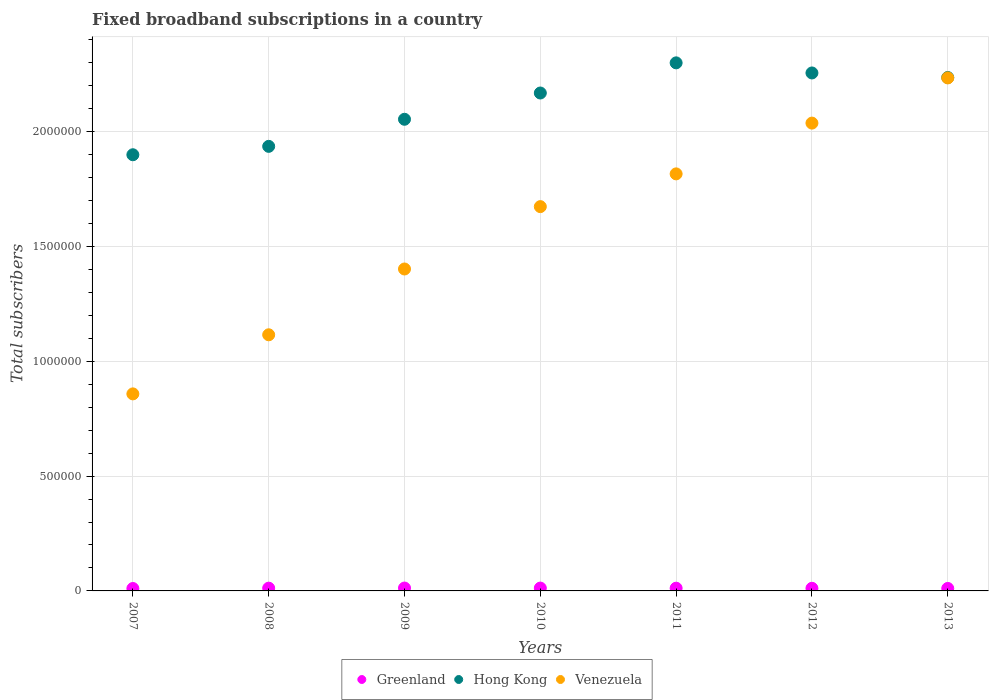How many different coloured dotlines are there?
Your answer should be compact. 3. What is the number of broadband subscriptions in Greenland in 2010?
Your answer should be compact. 1.24e+04. Across all years, what is the maximum number of broadband subscriptions in Venezuela?
Your answer should be compact. 2.23e+06. Across all years, what is the minimum number of broadband subscriptions in Greenland?
Provide a succinct answer. 1.05e+04. In which year was the number of broadband subscriptions in Venezuela minimum?
Your response must be concise. 2007. What is the total number of broadband subscriptions in Hong Kong in the graph?
Ensure brevity in your answer.  1.48e+07. What is the difference between the number of broadband subscriptions in Venezuela in 2008 and that in 2012?
Provide a short and direct response. -9.22e+05. What is the difference between the number of broadband subscriptions in Hong Kong in 2013 and the number of broadband subscriptions in Venezuela in 2007?
Offer a terse response. 1.38e+06. What is the average number of broadband subscriptions in Venezuela per year?
Provide a short and direct response. 1.59e+06. In the year 2012, what is the difference between the number of broadband subscriptions in Hong Kong and number of broadband subscriptions in Greenland?
Offer a terse response. 2.24e+06. What is the ratio of the number of broadband subscriptions in Venezuela in 2009 to that in 2010?
Provide a short and direct response. 0.84. Is the number of broadband subscriptions in Greenland in 2010 less than that in 2012?
Ensure brevity in your answer.  No. Is the difference between the number of broadband subscriptions in Hong Kong in 2009 and 2013 greater than the difference between the number of broadband subscriptions in Greenland in 2009 and 2013?
Your answer should be very brief. No. What is the difference between the highest and the second highest number of broadband subscriptions in Greenland?
Your answer should be compact. 150. What is the difference between the highest and the lowest number of broadband subscriptions in Hong Kong?
Your answer should be very brief. 4.00e+05. Is the sum of the number of broadband subscriptions in Greenland in 2009 and 2010 greater than the maximum number of broadband subscriptions in Venezuela across all years?
Provide a short and direct response. No. Is it the case that in every year, the sum of the number of broadband subscriptions in Venezuela and number of broadband subscriptions in Greenland  is greater than the number of broadband subscriptions in Hong Kong?
Provide a succinct answer. No. Is the number of broadband subscriptions in Greenland strictly greater than the number of broadband subscriptions in Hong Kong over the years?
Ensure brevity in your answer.  No. How many years are there in the graph?
Your answer should be very brief. 7. Does the graph contain any zero values?
Make the answer very short. No. Does the graph contain grids?
Give a very brief answer. Yes. Where does the legend appear in the graph?
Give a very brief answer. Bottom center. How many legend labels are there?
Your response must be concise. 3. How are the legend labels stacked?
Your response must be concise. Horizontal. What is the title of the graph?
Provide a short and direct response. Fixed broadband subscriptions in a country. Does "Central Europe" appear as one of the legend labels in the graph?
Your answer should be compact. No. What is the label or title of the Y-axis?
Keep it short and to the point. Total subscribers. What is the Total subscribers of Greenland in 2007?
Your answer should be very brief. 1.05e+04. What is the Total subscribers in Hong Kong in 2007?
Give a very brief answer. 1.90e+06. What is the Total subscribers of Venezuela in 2007?
Provide a short and direct response. 8.58e+05. What is the Total subscribers of Greenland in 2008?
Ensure brevity in your answer.  1.20e+04. What is the Total subscribers of Hong Kong in 2008?
Keep it short and to the point. 1.94e+06. What is the Total subscribers of Venezuela in 2008?
Keep it short and to the point. 1.12e+06. What is the Total subscribers in Greenland in 2009?
Offer a very short reply. 1.25e+04. What is the Total subscribers of Hong Kong in 2009?
Provide a short and direct response. 2.05e+06. What is the Total subscribers in Venezuela in 2009?
Offer a terse response. 1.40e+06. What is the Total subscribers of Greenland in 2010?
Give a very brief answer. 1.24e+04. What is the Total subscribers of Hong Kong in 2010?
Provide a short and direct response. 2.17e+06. What is the Total subscribers in Venezuela in 2010?
Give a very brief answer. 1.67e+06. What is the Total subscribers in Greenland in 2011?
Provide a short and direct response. 1.19e+04. What is the Total subscribers in Hong Kong in 2011?
Provide a short and direct response. 2.30e+06. What is the Total subscribers of Venezuela in 2011?
Your answer should be compact. 1.82e+06. What is the Total subscribers in Greenland in 2012?
Offer a terse response. 1.14e+04. What is the Total subscribers in Hong Kong in 2012?
Offer a very short reply. 2.26e+06. What is the Total subscribers of Venezuela in 2012?
Keep it short and to the point. 2.04e+06. What is the Total subscribers in Greenland in 2013?
Your answer should be compact. 1.08e+04. What is the Total subscribers of Hong Kong in 2013?
Your response must be concise. 2.24e+06. What is the Total subscribers of Venezuela in 2013?
Keep it short and to the point. 2.23e+06. Across all years, what is the maximum Total subscribers of Greenland?
Your response must be concise. 1.25e+04. Across all years, what is the maximum Total subscribers in Hong Kong?
Keep it short and to the point. 2.30e+06. Across all years, what is the maximum Total subscribers in Venezuela?
Provide a succinct answer. 2.23e+06. Across all years, what is the minimum Total subscribers of Greenland?
Make the answer very short. 1.05e+04. Across all years, what is the minimum Total subscribers in Hong Kong?
Give a very brief answer. 1.90e+06. Across all years, what is the minimum Total subscribers of Venezuela?
Keep it short and to the point. 8.58e+05. What is the total Total subscribers of Greenland in the graph?
Make the answer very short. 8.16e+04. What is the total Total subscribers in Hong Kong in the graph?
Keep it short and to the point. 1.48e+07. What is the total Total subscribers of Venezuela in the graph?
Keep it short and to the point. 1.11e+07. What is the difference between the Total subscribers in Greenland in 2007 and that in 2008?
Offer a terse response. -1466. What is the difference between the Total subscribers of Hong Kong in 2007 and that in 2008?
Your answer should be compact. -3.66e+04. What is the difference between the Total subscribers in Venezuela in 2007 and that in 2008?
Your answer should be very brief. -2.57e+05. What is the difference between the Total subscribers of Greenland in 2007 and that in 2009?
Your answer should be very brief. -1993. What is the difference between the Total subscribers of Hong Kong in 2007 and that in 2009?
Offer a very short reply. -1.54e+05. What is the difference between the Total subscribers in Venezuela in 2007 and that in 2009?
Give a very brief answer. -5.44e+05. What is the difference between the Total subscribers in Greenland in 2007 and that in 2010?
Give a very brief answer. -1843. What is the difference between the Total subscribers in Hong Kong in 2007 and that in 2010?
Your response must be concise. -2.69e+05. What is the difference between the Total subscribers in Venezuela in 2007 and that in 2010?
Your answer should be very brief. -8.15e+05. What is the difference between the Total subscribers of Greenland in 2007 and that in 2011?
Ensure brevity in your answer.  -1344. What is the difference between the Total subscribers in Hong Kong in 2007 and that in 2011?
Offer a terse response. -4.00e+05. What is the difference between the Total subscribers of Venezuela in 2007 and that in 2011?
Make the answer very short. -9.58e+05. What is the difference between the Total subscribers of Greenland in 2007 and that in 2012?
Provide a succinct answer. -833. What is the difference between the Total subscribers in Hong Kong in 2007 and that in 2012?
Keep it short and to the point. -3.56e+05. What is the difference between the Total subscribers in Venezuela in 2007 and that in 2012?
Your answer should be compact. -1.18e+06. What is the difference between the Total subscribers of Greenland in 2007 and that in 2013?
Your answer should be very brief. -253. What is the difference between the Total subscribers in Hong Kong in 2007 and that in 2013?
Ensure brevity in your answer.  -3.36e+05. What is the difference between the Total subscribers in Venezuela in 2007 and that in 2013?
Your answer should be compact. -1.38e+06. What is the difference between the Total subscribers in Greenland in 2008 and that in 2009?
Make the answer very short. -527. What is the difference between the Total subscribers of Hong Kong in 2008 and that in 2009?
Offer a very short reply. -1.18e+05. What is the difference between the Total subscribers in Venezuela in 2008 and that in 2009?
Your answer should be very brief. -2.86e+05. What is the difference between the Total subscribers of Greenland in 2008 and that in 2010?
Provide a succinct answer. -377. What is the difference between the Total subscribers in Hong Kong in 2008 and that in 2010?
Offer a very short reply. -2.32e+05. What is the difference between the Total subscribers in Venezuela in 2008 and that in 2010?
Keep it short and to the point. -5.58e+05. What is the difference between the Total subscribers of Greenland in 2008 and that in 2011?
Give a very brief answer. 122. What is the difference between the Total subscribers of Hong Kong in 2008 and that in 2011?
Ensure brevity in your answer.  -3.64e+05. What is the difference between the Total subscribers of Venezuela in 2008 and that in 2011?
Your answer should be compact. -7.01e+05. What is the difference between the Total subscribers in Greenland in 2008 and that in 2012?
Offer a very short reply. 633. What is the difference between the Total subscribers in Hong Kong in 2008 and that in 2012?
Keep it short and to the point. -3.20e+05. What is the difference between the Total subscribers in Venezuela in 2008 and that in 2012?
Offer a very short reply. -9.22e+05. What is the difference between the Total subscribers of Greenland in 2008 and that in 2013?
Offer a terse response. 1213. What is the difference between the Total subscribers in Hong Kong in 2008 and that in 2013?
Offer a very short reply. -3.00e+05. What is the difference between the Total subscribers of Venezuela in 2008 and that in 2013?
Your answer should be compact. -1.12e+06. What is the difference between the Total subscribers of Greenland in 2009 and that in 2010?
Provide a succinct answer. 150. What is the difference between the Total subscribers of Hong Kong in 2009 and that in 2010?
Offer a terse response. -1.14e+05. What is the difference between the Total subscribers of Venezuela in 2009 and that in 2010?
Ensure brevity in your answer.  -2.72e+05. What is the difference between the Total subscribers in Greenland in 2009 and that in 2011?
Give a very brief answer. 649. What is the difference between the Total subscribers of Hong Kong in 2009 and that in 2011?
Give a very brief answer. -2.46e+05. What is the difference between the Total subscribers of Venezuela in 2009 and that in 2011?
Your answer should be very brief. -4.14e+05. What is the difference between the Total subscribers of Greenland in 2009 and that in 2012?
Ensure brevity in your answer.  1160. What is the difference between the Total subscribers of Hong Kong in 2009 and that in 2012?
Give a very brief answer. -2.02e+05. What is the difference between the Total subscribers of Venezuela in 2009 and that in 2012?
Offer a very short reply. -6.35e+05. What is the difference between the Total subscribers of Greenland in 2009 and that in 2013?
Your response must be concise. 1740. What is the difference between the Total subscribers in Hong Kong in 2009 and that in 2013?
Your answer should be compact. -1.82e+05. What is the difference between the Total subscribers of Venezuela in 2009 and that in 2013?
Offer a terse response. -8.32e+05. What is the difference between the Total subscribers of Greenland in 2010 and that in 2011?
Provide a short and direct response. 499. What is the difference between the Total subscribers of Hong Kong in 2010 and that in 2011?
Ensure brevity in your answer.  -1.31e+05. What is the difference between the Total subscribers of Venezuela in 2010 and that in 2011?
Offer a terse response. -1.43e+05. What is the difference between the Total subscribers of Greenland in 2010 and that in 2012?
Give a very brief answer. 1010. What is the difference between the Total subscribers in Hong Kong in 2010 and that in 2012?
Provide a short and direct response. -8.73e+04. What is the difference between the Total subscribers of Venezuela in 2010 and that in 2012?
Offer a very short reply. -3.64e+05. What is the difference between the Total subscribers in Greenland in 2010 and that in 2013?
Make the answer very short. 1590. What is the difference between the Total subscribers of Hong Kong in 2010 and that in 2013?
Provide a short and direct response. -6.75e+04. What is the difference between the Total subscribers of Venezuela in 2010 and that in 2013?
Keep it short and to the point. -5.60e+05. What is the difference between the Total subscribers of Greenland in 2011 and that in 2012?
Provide a succinct answer. 511. What is the difference between the Total subscribers in Hong Kong in 2011 and that in 2012?
Offer a very short reply. 4.40e+04. What is the difference between the Total subscribers in Venezuela in 2011 and that in 2012?
Offer a very short reply. -2.21e+05. What is the difference between the Total subscribers in Greenland in 2011 and that in 2013?
Ensure brevity in your answer.  1091. What is the difference between the Total subscribers of Hong Kong in 2011 and that in 2013?
Give a very brief answer. 6.38e+04. What is the difference between the Total subscribers of Venezuela in 2011 and that in 2013?
Provide a short and direct response. -4.18e+05. What is the difference between the Total subscribers in Greenland in 2012 and that in 2013?
Offer a very short reply. 580. What is the difference between the Total subscribers in Hong Kong in 2012 and that in 2013?
Ensure brevity in your answer.  1.98e+04. What is the difference between the Total subscribers in Venezuela in 2012 and that in 2013?
Provide a short and direct response. -1.97e+05. What is the difference between the Total subscribers of Greenland in 2007 and the Total subscribers of Hong Kong in 2008?
Offer a terse response. -1.92e+06. What is the difference between the Total subscribers of Greenland in 2007 and the Total subscribers of Venezuela in 2008?
Your response must be concise. -1.10e+06. What is the difference between the Total subscribers of Hong Kong in 2007 and the Total subscribers of Venezuela in 2008?
Your answer should be very brief. 7.84e+05. What is the difference between the Total subscribers of Greenland in 2007 and the Total subscribers of Hong Kong in 2009?
Your answer should be very brief. -2.04e+06. What is the difference between the Total subscribers of Greenland in 2007 and the Total subscribers of Venezuela in 2009?
Keep it short and to the point. -1.39e+06. What is the difference between the Total subscribers of Hong Kong in 2007 and the Total subscribers of Venezuela in 2009?
Ensure brevity in your answer.  4.97e+05. What is the difference between the Total subscribers of Greenland in 2007 and the Total subscribers of Hong Kong in 2010?
Make the answer very short. -2.16e+06. What is the difference between the Total subscribers of Greenland in 2007 and the Total subscribers of Venezuela in 2010?
Your answer should be compact. -1.66e+06. What is the difference between the Total subscribers of Hong Kong in 2007 and the Total subscribers of Venezuela in 2010?
Your answer should be very brief. 2.26e+05. What is the difference between the Total subscribers in Greenland in 2007 and the Total subscribers in Hong Kong in 2011?
Your answer should be very brief. -2.29e+06. What is the difference between the Total subscribers of Greenland in 2007 and the Total subscribers of Venezuela in 2011?
Your response must be concise. -1.81e+06. What is the difference between the Total subscribers of Hong Kong in 2007 and the Total subscribers of Venezuela in 2011?
Offer a very short reply. 8.33e+04. What is the difference between the Total subscribers in Greenland in 2007 and the Total subscribers in Hong Kong in 2012?
Provide a succinct answer. -2.24e+06. What is the difference between the Total subscribers of Greenland in 2007 and the Total subscribers of Venezuela in 2012?
Ensure brevity in your answer.  -2.03e+06. What is the difference between the Total subscribers in Hong Kong in 2007 and the Total subscribers in Venezuela in 2012?
Keep it short and to the point. -1.38e+05. What is the difference between the Total subscribers of Greenland in 2007 and the Total subscribers of Hong Kong in 2013?
Provide a succinct answer. -2.22e+06. What is the difference between the Total subscribers in Greenland in 2007 and the Total subscribers in Venezuela in 2013?
Your response must be concise. -2.22e+06. What is the difference between the Total subscribers of Hong Kong in 2007 and the Total subscribers of Venezuela in 2013?
Your answer should be very brief. -3.34e+05. What is the difference between the Total subscribers of Greenland in 2008 and the Total subscribers of Hong Kong in 2009?
Give a very brief answer. -2.04e+06. What is the difference between the Total subscribers of Greenland in 2008 and the Total subscribers of Venezuela in 2009?
Your answer should be very brief. -1.39e+06. What is the difference between the Total subscribers in Hong Kong in 2008 and the Total subscribers in Venezuela in 2009?
Your answer should be compact. 5.34e+05. What is the difference between the Total subscribers in Greenland in 2008 and the Total subscribers in Hong Kong in 2010?
Your answer should be very brief. -2.16e+06. What is the difference between the Total subscribers in Greenland in 2008 and the Total subscribers in Venezuela in 2010?
Provide a succinct answer. -1.66e+06. What is the difference between the Total subscribers of Hong Kong in 2008 and the Total subscribers of Venezuela in 2010?
Your answer should be very brief. 2.62e+05. What is the difference between the Total subscribers of Greenland in 2008 and the Total subscribers of Hong Kong in 2011?
Your response must be concise. -2.29e+06. What is the difference between the Total subscribers of Greenland in 2008 and the Total subscribers of Venezuela in 2011?
Offer a terse response. -1.80e+06. What is the difference between the Total subscribers in Hong Kong in 2008 and the Total subscribers in Venezuela in 2011?
Give a very brief answer. 1.20e+05. What is the difference between the Total subscribers of Greenland in 2008 and the Total subscribers of Hong Kong in 2012?
Your response must be concise. -2.24e+06. What is the difference between the Total subscribers of Greenland in 2008 and the Total subscribers of Venezuela in 2012?
Keep it short and to the point. -2.02e+06. What is the difference between the Total subscribers of Hong Kong in 2008 and the Total subscribers of Venezuela in 2012?
Give a very brief answer. -1.01e+05. What is the difference between the Total subscribers of Greenland in 2008 and the Total subscribers of Hong Kong in 2013?
Offer a terse response. -2.22e+06. What is the difference between the Total subscribers in Greenland in 2008 and the Total subscribers in Venezuela in 2013?
Keep it short and to the point. -2.22e+06. What is the difference between the Total subscribers in Hong Kong in 2008 and the Total subscribers in Venezuela in 2013?
Give a very brief answer. -2.98e+05. What is the difference between the Total subscribers of Greenland in 2009 and the Total subscribers of Hong Kong in 2010?
Provide a short and direct response. -2.16e+06. What is the difference between the Total subscribers of Greenland in 2009 and the Total subscribers of Venezuela in 2010?
Offer a very short reply. -1.66e+06. What is the difference between the Total subscribers of Hong Kong in 2009 and the Total subscribers of Venezuela in 2010?
Make the answer very short. 3.80e+05. What is the difference between the Total subscribers in Greenland in 2009 and the Total subscribers in Hong Kong in 2011?
Your answer should be very brief. -2.29e+06. What is the difference between the Total subscribers in Greenland in 2009 and the Total subscribers in Venezuela in 2011?
Your answer should be very brief. -1.80e+06. What is the difference between the Total subscribers in Hong Kong in 2009 and the Total subscribers in Venezuela in 2011?
Provide a succinct answer. 2.38e+05. What is the difference between the Total subscribers of Greenland in 2009 and the Total subscribers of Hong Kong in 2012?
Your answer should be very brief. -2.24e+06. What is the difference between the Total subscribers of Greenland in 2009 and the Total subscribers of Venezuela in 2012?
Your answer should be compact. -2.02e+06. What is the difference between the Total subscribers of Hong Kong in 2009 and the Total subscribers of Venezuela in 2012?
Offer a very short reply. 1.67e+04. What is the difference between the Total subscribers in Greenland in 2009 and the Total subscribers in Hong Kong in 2013?
Ensure brevity in your answer.  -2.22e+06. What is the difference between the Total subscribers of Greenland in 2009 and the Total subscribers of Venezuela in 2013?
Your response must be concise. -2.22e+06. What is the difference between the Total subscribers in Hong Kong in 2009 and the Total subscribers in Venezuela in 2013?
Ensure brevity in your answer.  -1.80e+05. What is the difference between the Total subscribers in Greenland in 2010 and the Total subscribers in Hong Kong in 2011?
Give a very brief answer. -2.29e+06. What is the difference between the Total subscribers of Greenland in 2010 and the Total subscribers of Venezuela in 2011?
Your answer should be very brief. -1.80e+06. What is the difference between the Total subscribers in Hong Kong in 2010 and the Total subscribers in Venezuela in 2011?
Ensure brevity in your answer.  3.52e+05. What is the difference between the Total subscribers in Greenland in 2010 and the Total subscribers in Hong Kong in 2012?
Ensure brevity in your answer.  -2.24e+06. What is the difference between the Total subscribers in Greenland in 2010 and the Total subscribers in Venezuela in 2012?
Keep it short and to the point. -2.02e+06. What is the difference between the Total subscribers of Hong Kong in 2010 and the Total subscribers of Venezuela in 2012?
Your answer should be compact. 1.31e+05. What is the difference between the Total subscribers in Greenland in 2010 and the Total subscribers in Hong Kong in 2013?
Your response must be concise. -2.22e+06. What is the difference between the Total subscribers in Greenland in 2010 and the Total subscribers in Venezuela in 2013?
Make the answer very short. -2.22e+06. What is the difference between the Total subscribers of Hong Kong in 2010 and the Total subscribers of Venezuela in 2013?
Provide a succinct answer. -6.57e+04. What is the difference between the Total subscribers in Greenland in 2011 and the Total subscribers in Hong Kong in 2012?
Make the answer very short. -2.24e+06. What is the difference between the Total subscribers in Greenland in 2011 and the Total subscribers in Venezuela in 2012?
Keep it short and to the point. -2.02e+06. What is the difference between the Total subscribers in Hong Kong in 2011 and the Total subscribers in Venezuela in 2012?
Make the answer very short. 2.62e+05. What is the difference between the Total subscribers of Greenland in 2011 and the Total subscribers of Hong Kong in 2013?
Your answer should be very brief. -2.22e+06. What is the difference between the Total subscribers of Greenland in 2011 and the Total subscribers of Venezuela in 2013?
Your response must be concise. -2.22e+06. What is the difference between the Total subscribers of Hong Kong in 2011 and the Total subscribers of Venezuela in 2013?
Your answer should be compact. 6.56e+04. What is the difference between the Total subscribers of Greenland in 2012 and the Total subscribers of Hong Kong in 2013?
Your answer should be compact. -2.22e+06. What is the difference between the Total subscribers in Greenland in 2012 and the Total subscribers in Venezuela in 2013?
Make the answer very short. -2.22e+06. What is the difference between the Total subscribers in Hong Kong in 2012 and the Total subscribers in Venezuela in 2013?
Keep it short and to the point. 2.16e+04. What is the average Total subscribers of Greenland per year?
Give a very brief answer. 1.17e+04. What is the average Total subscribers of Hong Kong per year?
Your response must be concise. 2.12e+06. What is the average Total subscribers of Venezuela per year?
Keep it short and to the point. 1.59e+06. In the year 2007, what is the difference between the Total subscribers of Greenland and Total subscribers of Hong Kong?
Provide a succinct answer. -1.89e+06. In the year 2007, what is the difference between the Total subscribers in Greenland and Total subscribers in Venezuela?
Give a very brief answer. -8.47e+05. In the year 2007, what is the difference between the Total subscribers in Hong Kong and Total subscribers in Venezuela?
Keep it short and to the point. 1.04e+06. In the year 2008, what is the difference between the Total subscribers in Greenland and Total subscribers in Hong Kong?
Your answer should be very brief. -1.92e+06. In the year 2008, what is the difference between the Total subscribers of Greenland and Total subscribers of Venezuela?
Your response must be concise. -1.10e+06. In the year 2008, what is the difference between the Total subscribers of Hong Kong and Total subscribers of Venezuela?
Ensure brevity in your answer.  8.20e+05. In the year 2009, what is the difference between the Total subscribers of Greenland and Total subscribers of Hong Kong?
Ensure brevity in your answer.  -2.04e+06. In the year 2009, what is the difference between the Total subscribers of Greenland and Total subscribers of Venezuela?
Provide a short and direct response. -1.39e+06. In the year 2009, what is the difference between the Total subscribers of Hong Kong and Total subscribers of Venezuela?
Ensure brevity in your answer.  6.52e+05. In the year 2010, what is the difference between the Total subscribers in Greenland and Total subscribers in Hong Kong?
Provide a short and direct response. -2.16e+06. In the year 2010, what is the difference between the Total subscribers in Greenland and Total subscribers in Venezuela?
Provide a succinct answer. -1.66e+06. In the year 2010, what is the difference between the Total subscribers in Hong Kong and Total subscribers in Venezuela?
Offer a very short reply. 4.95e+05. In the year 2011, what is the difference between the Total subscribers of Greenland and Total subscribers of Hong Kong?
Offer a very short reply. -2.29e+06. In the year 2011, what is the difference between the Total subscribers in Greenland and Total subscribers in Venezuela?
Provide a short and direct response. -1.80e+06. In the year 2011, what is the difference between the Total subscribers in Hong Kong and Total subscribers in Venezuela?
Provide a succinct answer. 4.83e+05. In the year 2012, what is the difference between the Total subscribers of Greenland and Total subscribers of Hong Kong?
Your answer should be compact. -2.24e+06. In the year 2012, what is the difference between the Total subscribers of Greenland and Total subscribers of Venezuela?
Provide a succinct answer. -2.03e+06. In the year 2012, what is the difference between the Total subscribers of Hong Kong and Total subscribers of Venezuela?
Provide a succinct answer. 2.18e+05. In the year 2013, what is the difference between the Total subscribers in Greenland and Total subscribers in Hong Kong?
Provide a short and direct response. -2.22e+06. In the year 2013, what is the difference between the Total subscribers of Greenland and Total subscribers of Venezuela?
Keep it short and to the point. -2.22e+06. In the year 2013, what is the difference between the Total subscribers in Hong Kong and Total subscribers in Venezuela?
Provide a short and direct response. 1792. What is the ratio of the Total subscribers of Greenland in 2007 to that in 2008?
Give a very brief answer. 0.88. What is the ratio of the Total subscribers in Hong Kong in 2007 to that in 2008?
Offer a terse response. 0.98. What is the ratio of the Total subscribers in Venezuela in 2007 to that in 2008?
Offer a terse response. 0.77. What is the ratio of the Total subscribers of Greenland in 2007 to that in 2009?
Ensure brevity in your answer.  0.84. What is the ratio of the Total subscribers of Hong Kong in 2007 to that in 2009?
Your answer should be compact. 0.92. What is the ratio of the Total subscribers in Venezuela in 2007 to that in 2009?
Provide a succinct answer. 0.61. What is the ratio of the Total subscribers in Greenland in 2007 to that in 2010?
Offer a very short reply. 0.85. What is the ratio of the Total subscribers of Hong Kong in 2007 to that in 2010?
Offer a terse response. 0.88. What is the ratio of the Total subscribers of Venezuela in 2007 to that in 2010?
Offer a terse response. 0.51. What is the ratio of the Total subscribers in Greenland in 2007 to that in 2011?
Your answer should be very brief. 0.89. What is the ratio of the Total subscribers in Hong Kong in 2007 to that in 2011?
Keep it short and to the point. 0.83. What is the ratio of the Total subscribers of Venezuela in 2007 to that in 2011?
Your response must be concise. 0.47. What is the ratio of the Total subscribers of Greenland in 2007 to that in 2012?
Your answer should be compact. 0.93. What is the ratio of the Total subscribers in Hong Kong in 2007 to that in 2012?
Make the answer very short. 0.84. What is the ratio of the Total subscribers of Venezuela in 2007 to that in 2012?
Keep it short and to the point. 0.42. What is the ratio of the Total subscribers of Greenland in 2007 to that in 2013?
Offer a terse response. 0.98. What is the ratio of the Total subscribers of Hong Kong in 2007 to that in 2013?
Your answer should be compact. 0.85. What is the ratio of the Total subscribers of Venezuela in 2007 to that in 2013?
Make the answer very short. 0.38. What is the ratio of the Total subscribers of Greenland in 2008 to that in 2009?
Your response must be concise. 0.96. What is the ratio of the Total subscribers in Hong Kong in 2008 to that in 2009?
Keep it short and to the point. 0.94. What is the ratio of the Total subscribers of Venezuela in 2008 to that in 2009?
Offer a very short reply. 0.8. What is the ratio of the Total subscribers in Greenland in 2008 to that in 2010?
Give a very brief answer. 0.97. What is the ratio of the Total subscribers of Hong Kong in 2008 to that in 2010?
Keep it short and to the point. 0.89. What is the ratio of the Total subscribers in Venezuela in 2008 to that in 2010?
Your answer should be very brief. 0.67. What is the ratio of the Total subscribers of Greenland in 2008 to that in 2011?
Keep it short and to the point. 1.01. What is the ratio of the Total subscribers of Hong Kong in 2008 to that in 2011?
Your answer should be very brief. 0.84. What is the ratio of the Total subscribers of Venezuela in 2008 to that in 2011?
Your answer should be very brief. 0.61. What is the ratio of the Total subscribers in Greenland in 2008 to that in 2012?
Give a very brief answer. 1.06. What is the ratio of the Total subscribers in Hong Kong in 2008 to that in 2012?
Your response must be concise. 0.86. What is the ratio of the Total subscribers of Venezuela in 2008 to that in 2012?
Provide a short and direct response. 0.55. What is the ratio of the Total subscribers of Greenland in 2008 to that in 2013?
Keep it short and to the point. 1.11. What is the ratio of the Total subscribers of Hong Kong in 2008 to that in 2013?
Your answer should be very brief. 0.87. What is the ratio of the Total subscribers of Venezuela in 2008 to that in 2013?
Provide a short and direct response. 0.5. What is the ratio of the Total subscribers in Greenland in 2009 to that in 2010?
Ensure brevity in your answer.  1.01. What is the ratio of the Total subscribers in Hong Kong in 2009 to that in 2010?
Your answer should be very brief. 0.95. What is the ratio of the Total subscribers in Venezuela in 2009 to that in 2010?
Your answer should be compact. 0.84. What is the ratio of the Total subscribers in Greenland in 2009 to that in 2011?
Your answer should be very brief. 1.05. What is the ratio of the Total subscribers of Hong Kong in 2009 to that in 2011?
Offer a terse response. 0.89. What is the ratio of the Total subscribers of Venezuela in 2009 to that in 2011?
Provide a short and direct response. 0.77. What is the ratio of the Total subscribers of Greenland in 2009 to that in 2012?
Ensure brevity in your answer.  1.1. What is the ratio of the Total subscribers of Hong Kong in 2009 to that in 2012?
Your response must be concise. 0.91. What is the ratio of the Total subscribers of Venezuela in 2009 to that in 2012?
Your answer should be compact. 0.69. What is the ratio of the Total subscribers of Greenland in 2009 to that in 2013?
Offer a very short reply. 1.16. What is the ratio of the Total subscribers of Hong Kong in 2009 to that in 2013?
Offer a terse response. 0.92. What is the ratio of the Total subscribers of Venezuela in 2009 to that in 2013?
Your answer should be very brief. 0.63. What is the ratio of the Total subscribers of Greenland in 2010 to that in 2011?
Offer a very short reply. 1.04. What is the ratio of the Total subscribers in Hong Kong in 2010 to that in 2011?
Provide a succinct answer. 0.94. What is the ratio of the Total subscribers of Venezuela in 2010 to that in 2011?
Your answer should be very brief. 0.92. What is the ratio of the Total subscribers in Greenland in 2010 to that in 2012?
Your answer should be very brief. 1.09. What is the ratio of the Total subscribers of Hong Kong in 2010 to that in 2012?
Give a very brief answer. 0.96. What is the ratio of the Total subscribers in Venezuela in 2010 to that in 2012?
Offer a terse response. 0.82. What is the ratio of the Total subscribers in Greenland in 2010 to that in 2013?
Provide a succinct answer. 1.15. What is the ratio of the Total subscribers in Hong Kong in 2010 to that in 2013?
Make the answer very short. 0.97. What is the ratio of the Total subscribers of Venezuela in 2010 to that in 2013?
Give a very brief answer. 0.75. What is the ratio of the Total subscribers of Greenland in 2011 to that in 2012?
Your response must be concise. 1.04. What is the ratio of the Total subscribers of Hong Kong in 2011 to that in 2012?
Your response must be concise. 1.02. What is the ratio of the Total subscribers in Venezuela in 2011 to that in 2012?
Your answer should be very brief. 0.89. What is the ratio of the Total subscribers in Greenland in 2011 to that in 2013?
Provide a short and direct response. 1.1. What is the ratio of the Total subscribers of Hong Kong in 2011 to that in 2013?
Provide a short and direct response. 1.03. What is the ratio of the Total subscribers in Venezuela in 2011 to that in 2013?
Give a very brief answer. 0.81. What is the ratio of the Total subscribers in Greenland in 2012 to that in 2013?
Your answer should be very brief. 1.05. What is the ratio of the Total subscribers in Hong Kong in 2012 to that in 2013?
Offer a terse response. 1.01. What is the ratio of the Total subscribers of Venezuela in 2012 to that in 2013?
Make the answer very short. 0.91. What is the difference between the highest and the second highest Total subscribers in Greenland?
Provide a succinct answer. 150. What is the difference between the highest and the second highest Total subscribers of Hong Kong?
Give a very brief answer. 4.40e+04. What is the difference between the highest and the second highest Total subscribers of Venezuela?
Your response must be concise. 1.97e+05. What is the difference between the highest and the lowest Total subscribers of Greenland?
Your answer should be very brief. 1993. What is the difference between the highest and the lowest Total subscribers in Hong Kong?
Your response must be concise. 4.00e+05. What is the difference between the highest and the lowest Total subscribers in Venezuela?
Provide a succinct answer. 1.38e+06. 